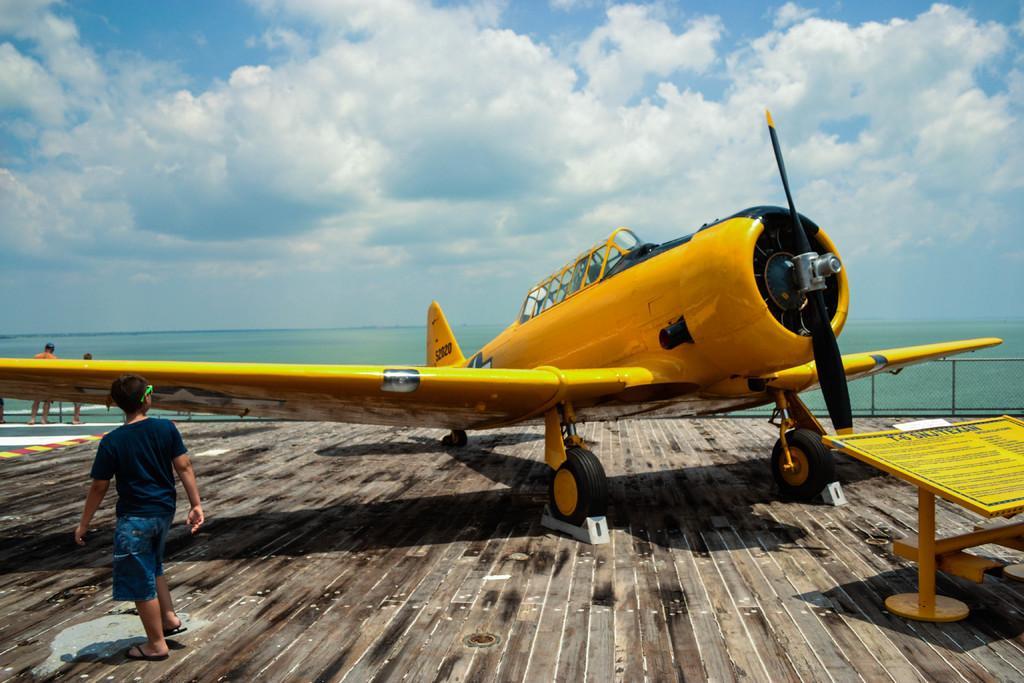Describe this image in one or two sentences. In this image, we can see a plane. We can see a board with some text written. There are a few people. We can see the wooden surface. We can see some water. We can see the fence. We can see the sky with clouds. 